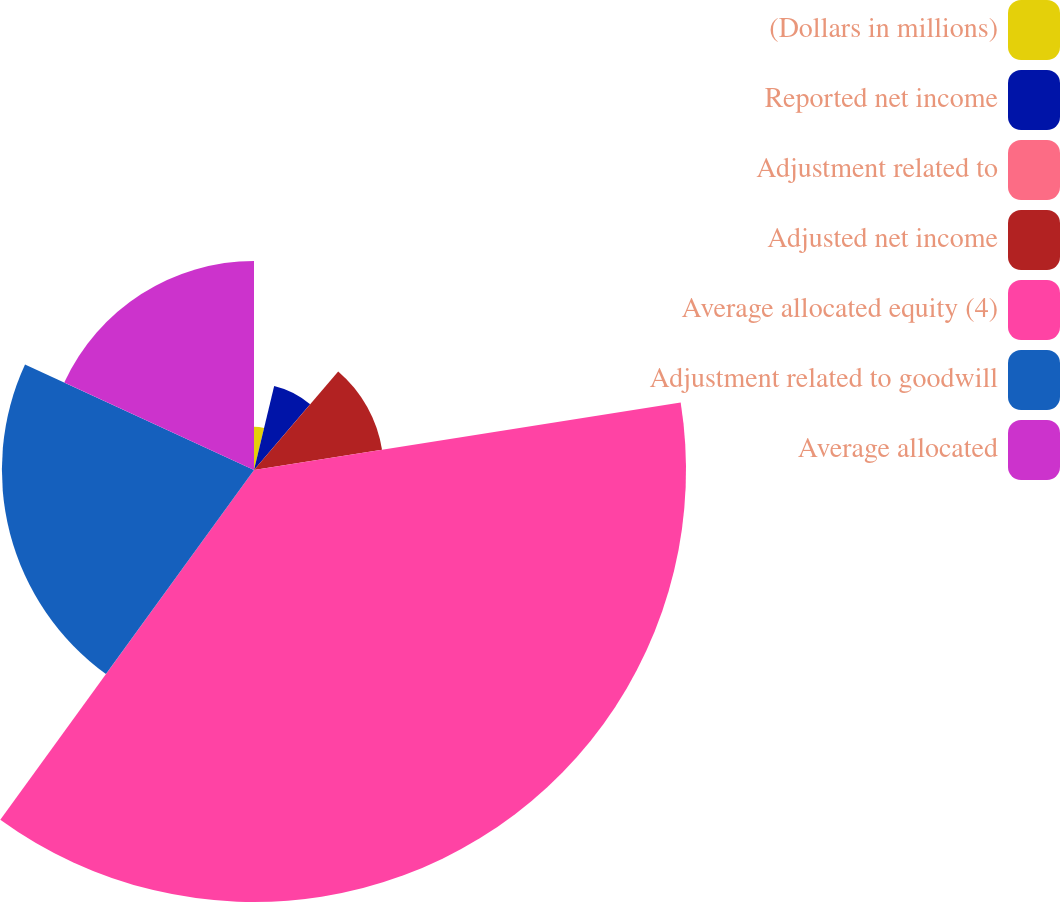<chart> <loc_0><loc_0><loc_500><loc_500><pie_chart><fcel>(Dollars in millions)<fcel>Reported net income<fcel>Adjustment related to<fcel>Adjusted net income<fcel>Average allocated equity (4)<fcel>Adjustment related to goodwill<fcel>Average allocated<nl><fcel>3.75%<fcel>7.5%<fcel>0.0%<fcel>11.25%<fcel>37.49%<fcel>21.88%<fcel>18.13%<nl></chart> 